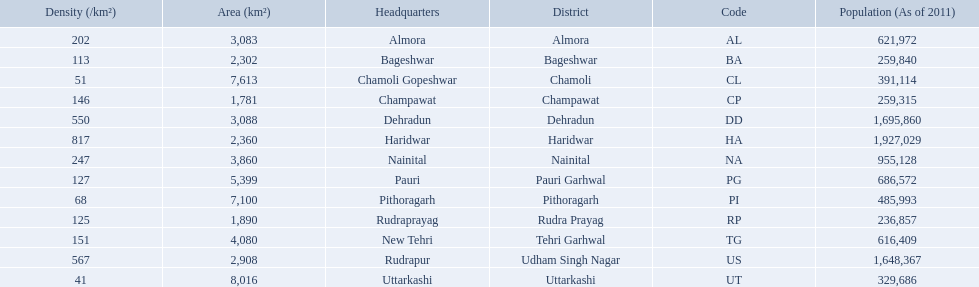What are all the districts? Almora, Bageshwar, Chamoli, Champawat, Dehradun, Haridwar, Nainital, Pauri Garhwal, Pithoragarh, Rudra Prayag, Tehri Garhwal, Udham Singh Nagar, Uttarkashi. And their densities? 202, 113, 51, 146, 550, 817, 247, 127, 68, 125, 151, 567, 41. Now, which district's density is 51? Chamoli. 